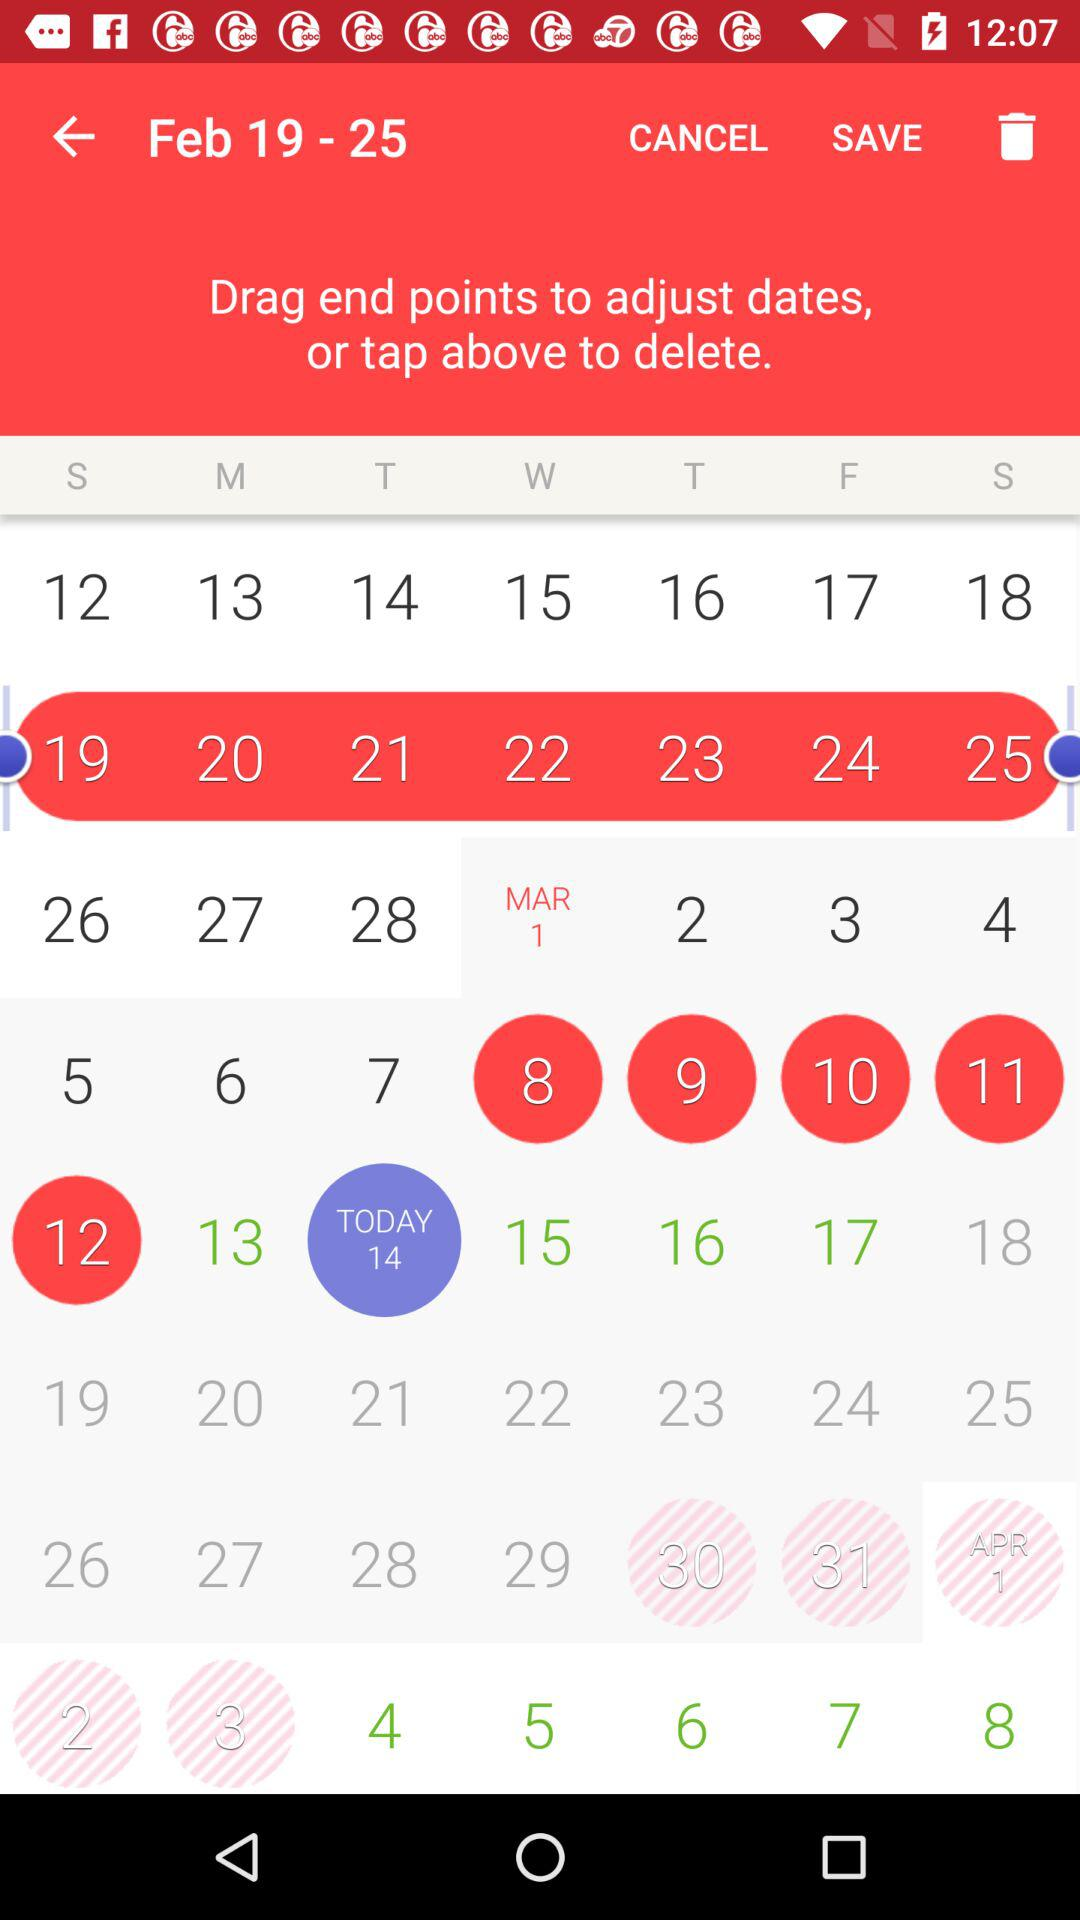What is the day on March 1? The day is Wednesday. 